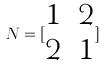<formula> <loc_0><loc_0><loc_500><loc_500>N = [ \begin{matrix} 1 & 2 \\ 2 & 1 \end{matrix} ]</formula> 